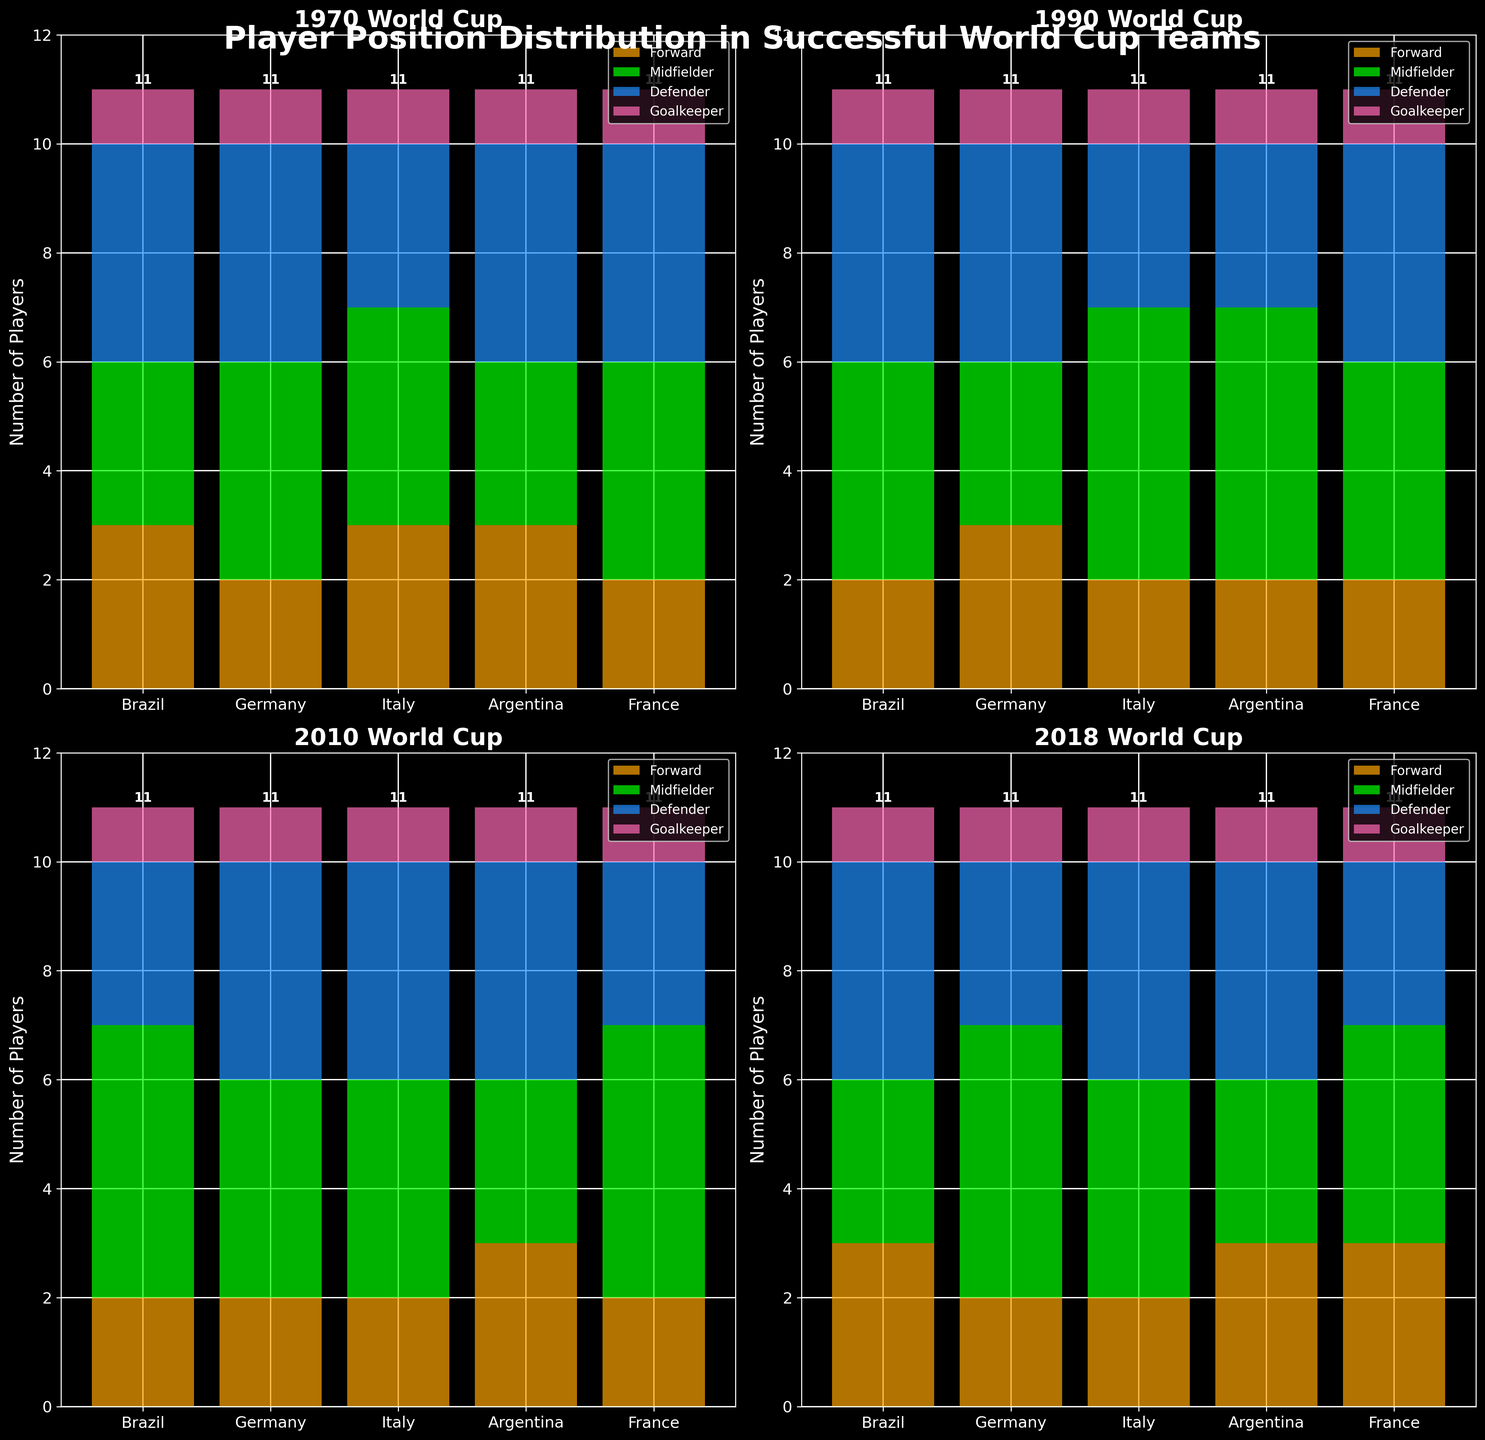What is the title of the figure? The title is located at the top center of the figure and is in large bold font.
Answer: Player Position Distribution in Successful World Cup Teams How many players did Brazil have in the Forward position in 1990? In the subplot for the 1990 World Cup, find Brazil along the x-axis and look at the segment of the bar labeled with the Forward position.
Answer: 2 Which country has the highest number of Midfielders in 2010? Look at the subplot for the 2010 World Cup, find the bar labeled "Midfielders" and compare the heights for each country.
Answer: Brazil How many more Defenders did Italy have compared to Argentina in 2010? In the 2010 subplot, find the Defender values for Italy and Argentina, then subtract the number of Argentine defenders from the number of Italian defenders.
Answer: 1 What is the average number of Forwards in all countries in the 2018 World Cup? For the 2018 subplot, sum the number of Forwards across all countries and divide by the number of countries. (3+2+2+3+3)/5
Answer: 2.6 Which position had the highest cumulative number of players across all countries in the 1970 World Cup? In the 1970 subplot, sum the number of players for each position across all countries and compare the totals to find the highest.
Answer: Midfielder How many players did Germany and France collectively have in the Goalkeeper position across all the years shown? Sum the number of Goalkeepers for Germany and France for each year (1970, 1990, 2010, 2018) and then add these sums together.
Answer: 8 Compare the total number of players in the Midfielder position between France and Argentina in the 2018 World Cup. In the 2018 subplot, note the bar height for Midfielders in both France and Argentina. France: 4, Argentina: 3.
Answer: France has 1 more midfielder than Argentina What is the total number of Defenders across all years for Brazil? Sum the number of Defenders in the Brazil bars across all subplots (4 in 1970, 4 in 1990, 3 in 2010, 4 in 2018).
Answer: 15 